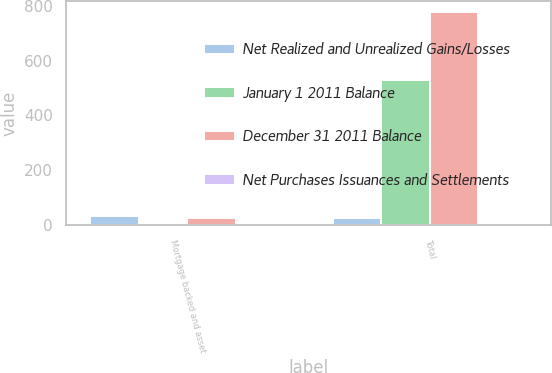<chart> <loc_0><loc_0><loc_500><loc_500><stacked_bar_chart><ecel><fcel>Mortgage backed and asset<fcel>Total<nl><fcel>Net Realized and Unrealized Gains/Losses<fcel>33<fcel>25<nl><fcel>January 1 2011 Balance<fcel>2<fcel>529<nl><fcel>December 31 2011 Balance<fcel>25<fcel>778<nl><fcel>Net Purchases Issuances and Settlements<fcel>1<fcel>2<nl></chart> 